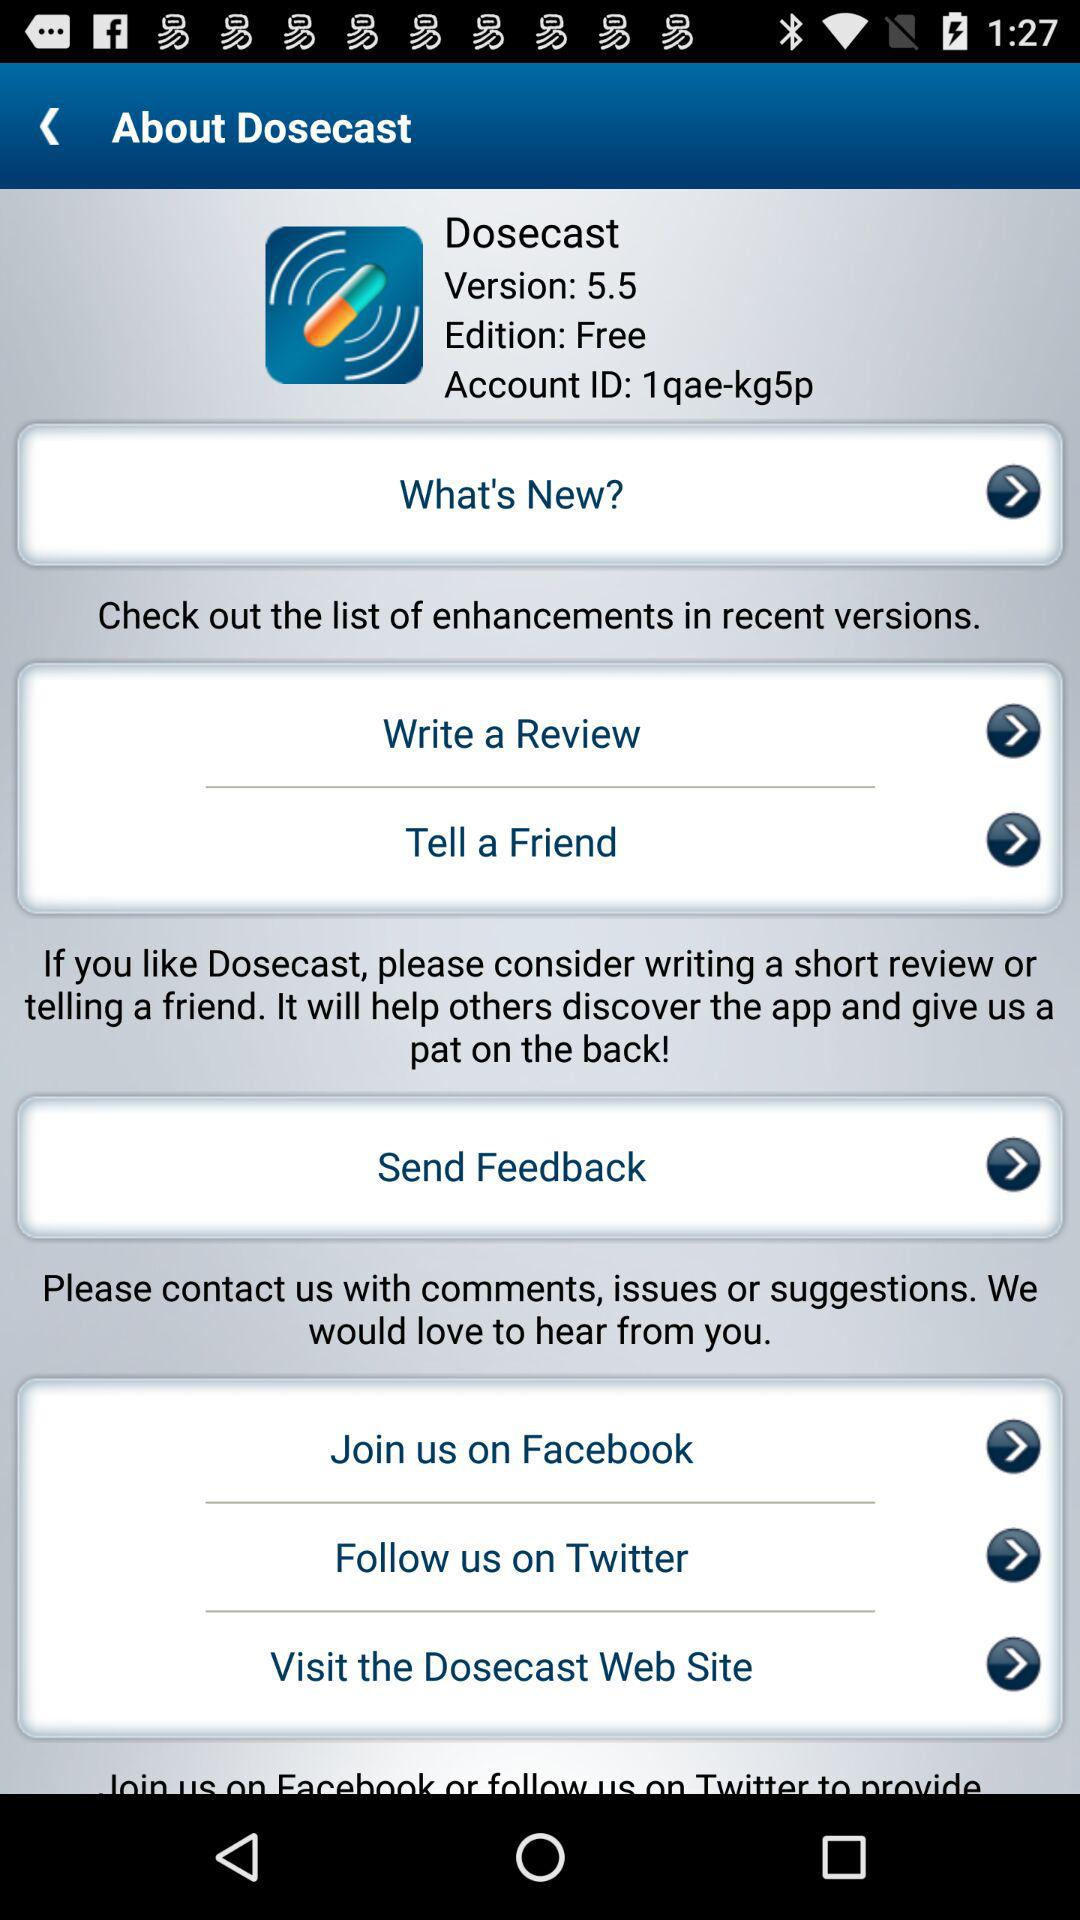Which is the current version? The current version is 5.5. 